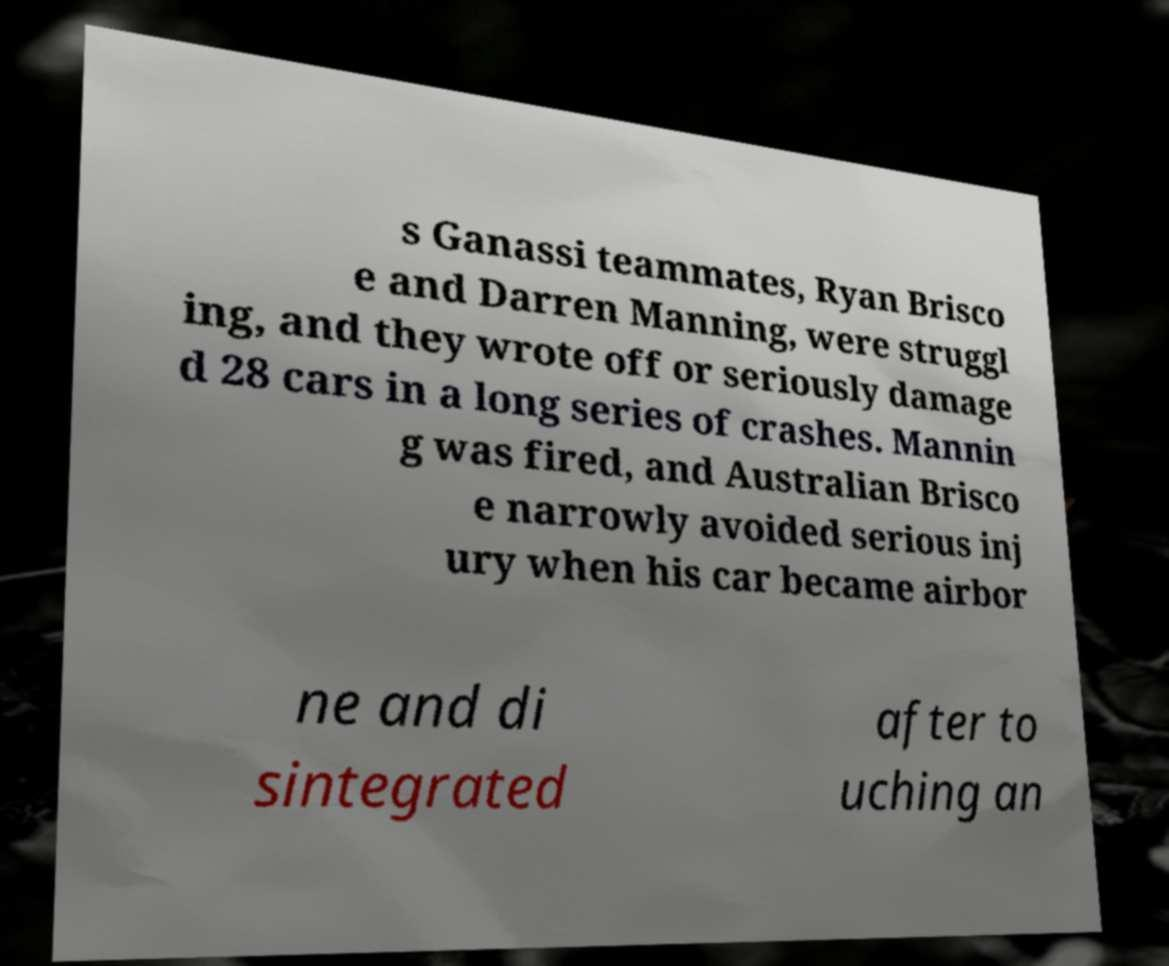Please read and relay the text visible in this image. What does it say? s Ganassi teammates, Ryan Brisco e and Darren Manning, were struggl ing, and they wrote off or seriously damage d 28 cars in a long series of crashes. Mannin g was fired, and Australian Brisco e narrowly avoided serious inj ury when his car became airbor ne and di sintegrated after to uching an 